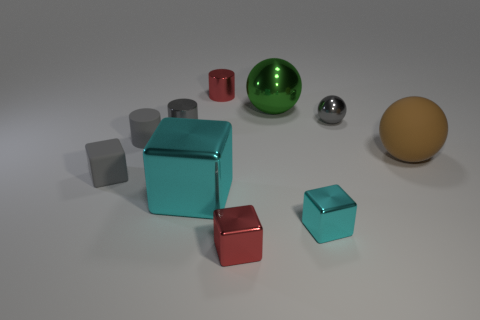Subtract all gray cylinders. How many cylinders are left? 1 Subtract all red blocks. How many blocks are left? 3 Subtract all cylinders. How many objects are left? 7 Subtract 1 cylinders. How many cylinders are left? 2 Add 7 red metal cylinders. How many red metal cylinders are left? 8 Add 3 gray matte objects. How many gray matte objects exist? 5 Subtract 0 blue blocks. How many objects are left? 10 Subtract all cyan cylinders. Subtract all gray blocks. How many cylinders are left? 3 Subtract all cyan spheres. How many blue blocks are left? 0 Subtract all small shiny spheres. Subtract all big brown rubber things. How many objects are left? 8 